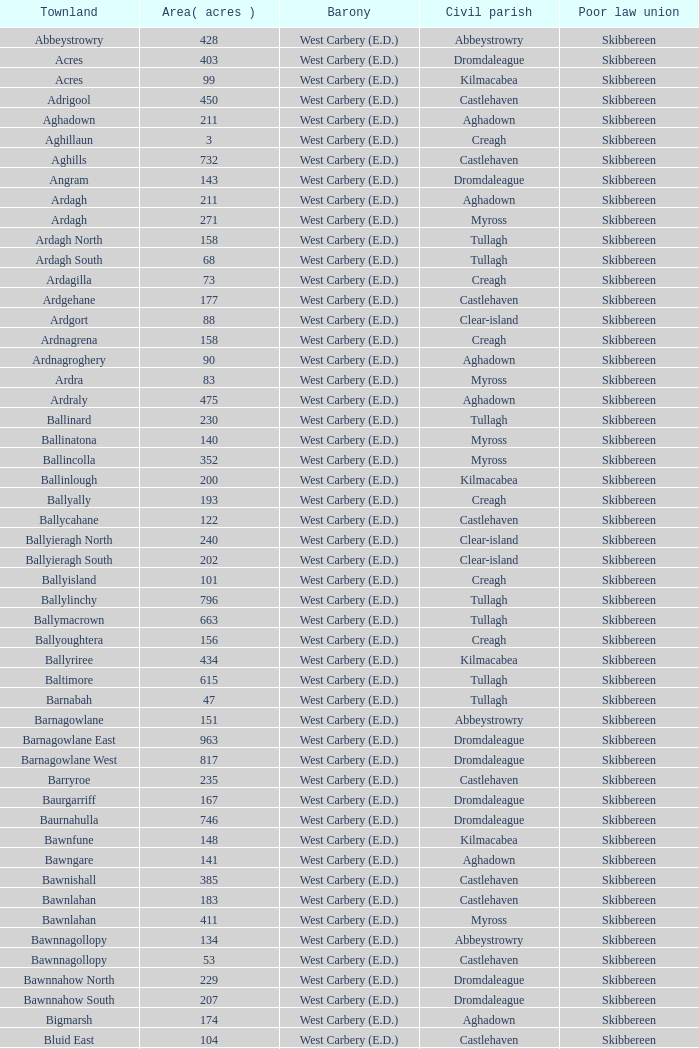In the skibbereen poor law union and the tullagh civil parish, what is the maximum area? 796.0. 